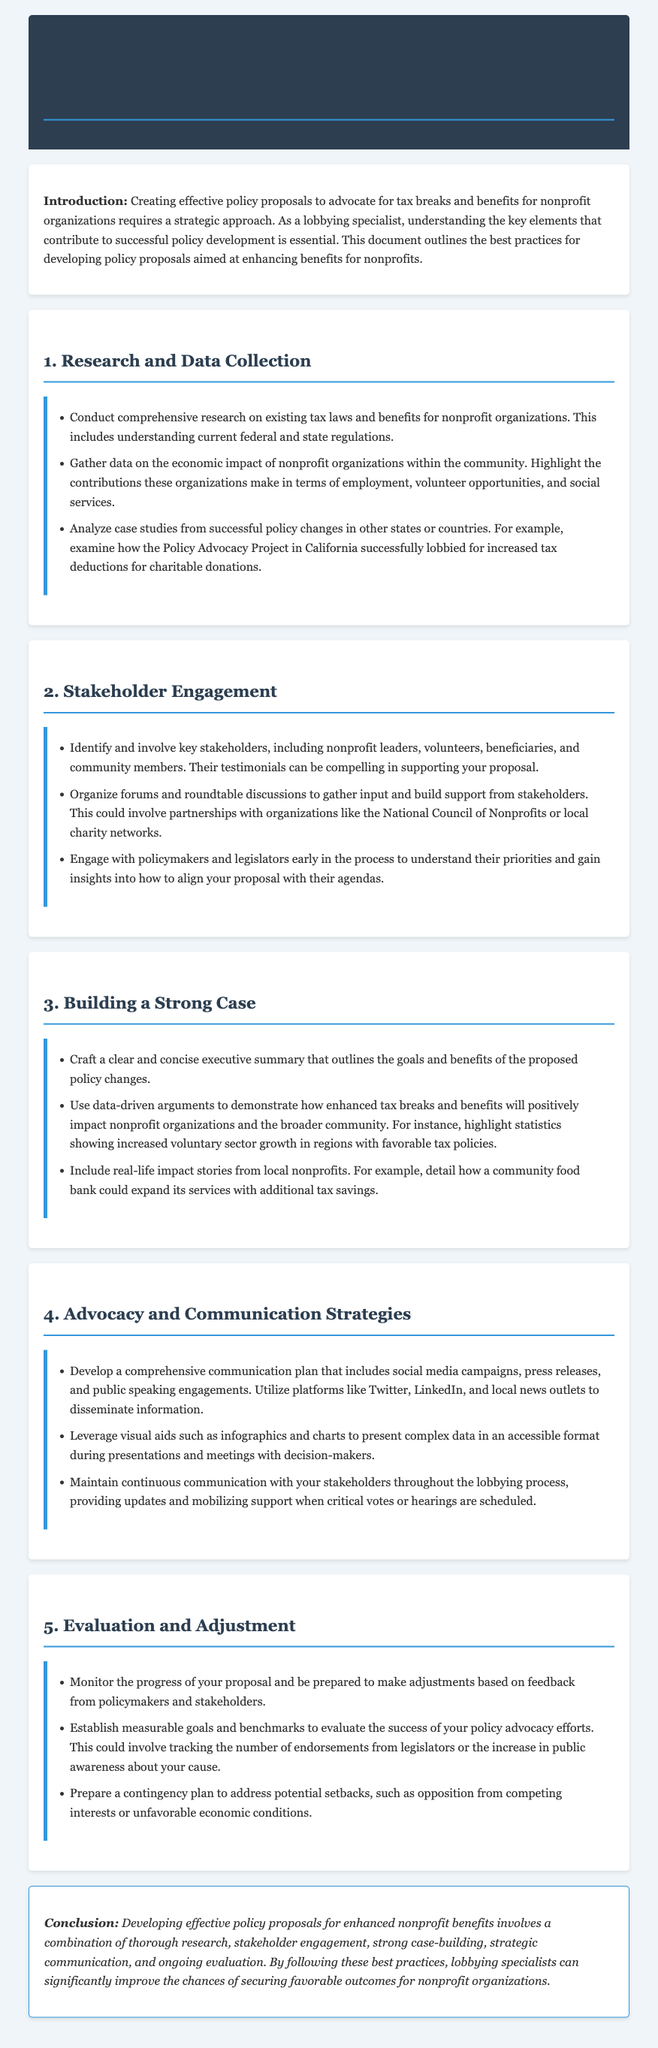What is the title of the homework? The title of the homework is the main heading of the document, providing a clear focus on the topic.
Answer: Homework: Best Practices for Developing Policy Proposals for Enhanced Nonprofit Benefits What is the first key practice mentioned in the document? The first key practice outlines the initial steps in the policy proposal development process, making it crucial for effective advocacy.
Answer: Research and Data Collection Which group is suggested to be identified and involved as key stakeholders? The document specifies certain groups that can provide valuable support and insight during the policy development process.
Answer: Nonprofit leaders What type of communication plan should be developed? The document emphasizes the importance of a comprehensive approach to ensure effective outreach during advocacy efforts.
Answer: Comprehensive communication plan What is a suggested activity to gather input from stakeholders? This activity serves to evaluate perspectives and build support for the proposal through direct engagement with the community.
Answer: Organize forums and roundtable discussions What is the conclusion of the document? The conclusion summarizes the importance of several key practices in order to advocate effectively for nonprofit organizations.
Answer: Developing effective policy proposals for enhanced nonprofit benefits involves a combination of thorough research, stakeholder engagement, strong case-building, strategic communication, and ongoing evaluation 